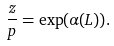Convert formula to latex. <formula><loc_0><loc_0><loc_500><loc_500>\frac { z } { p } = \exp ( \alpha ( L ) ) .</formula> 